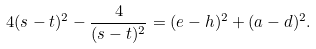Convert formula to latex. <formula><loc_0><loc_0><loc_500><loc_500>4 ( s - t ) ^ { 2 } - \frac { 4 } { ( s - t ) ^ { 2 } } = ( e - h ) ^ { 2 } + ( a - d ) ^ { 2 } .</formula> 